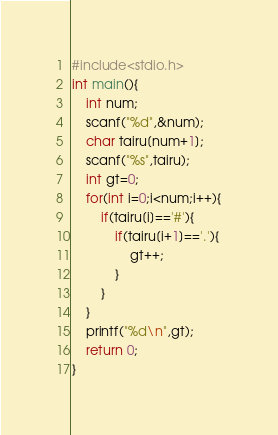<code> <loc_0><loc_0><loc_500><loc_500><_C++_>#include<stdio.h>
int main(){
    int num;
    scanf("%d",&num);
    char tairu[num+1];
    scanf("%s",tairu);
    int gt=0;
    for(int i=0;i<num;i++){
        if(tairu[i]=='#'){
            if(tairu[i+1]=='.'){
                gt++;
            }
        }
    }
    printf("%d\n",gt);
    return 0;
}</code> 